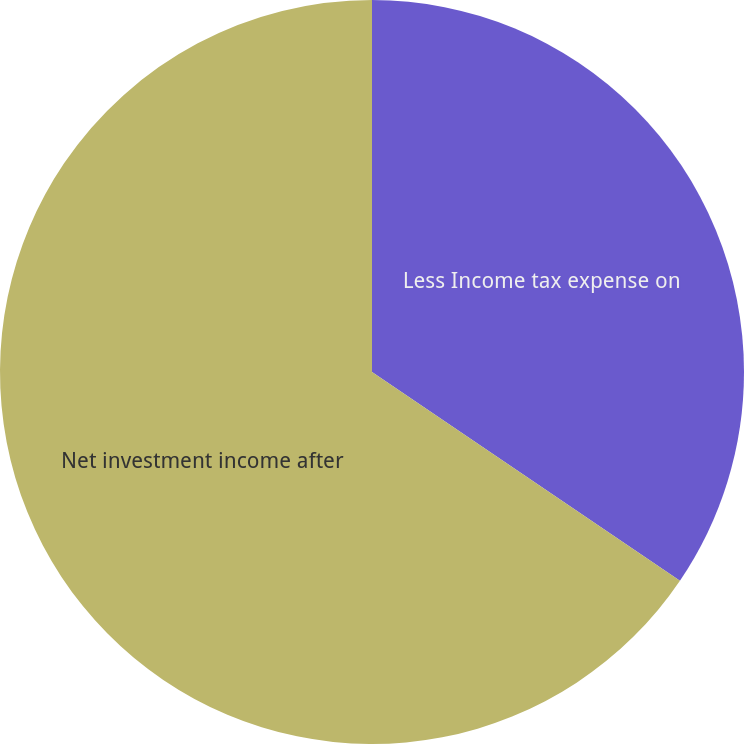Convert chart to OTSL. <chart><loc_0><loc_0><loc_500><loc_500><pie_chart><fcel>Less Income tax expense on<fcel>Net investment income after<nl><fcel>34.48%<fcel>65.52%<nl></chart> 